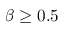<formula> <loc_0><loc_0><loc_500><loc_500>\beta \geq 0 . 5</formula> 